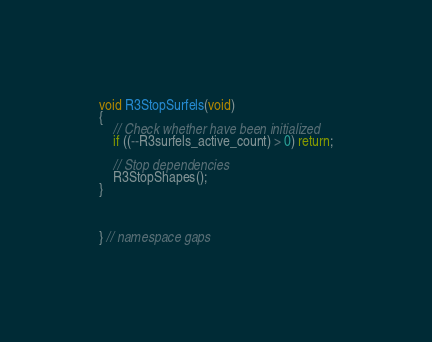<code> <loc_0><loc_0><loc_500><loc_500><_C++_>
void R3StopSurfels(void)
{
    // Check whether have been initialized 
    if ((--R3surfels_active_count) > 0) return;

    // Stop dependencies
    R3StopShapes();
}



} // namespace gaps
</code> 